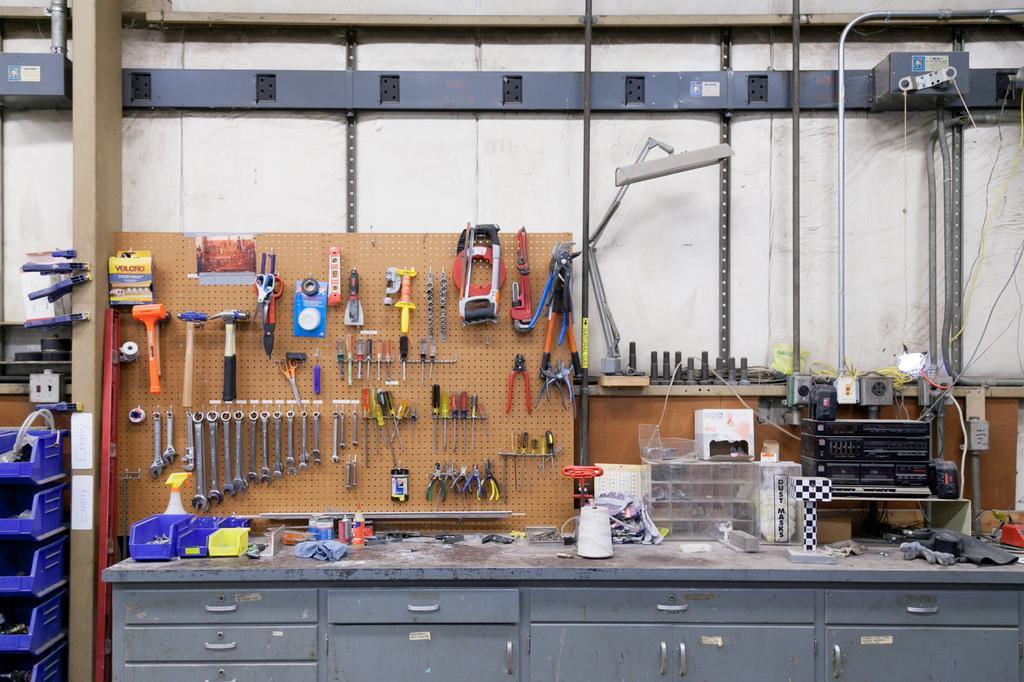How would you summarize this image in a sentence or two? At the bottom of the image there is a table with cupboards, bottles, black machine and some other things. There is a board behind the table with hammers, screwdrivers, cutting pliers, scissors and many other tools. Behind the board there is a wall with pipes, poles, wires and a box. And also there are many other things on the wall. On the left of the image there are blue boxes and also some other things. There is a wooden pole with a few things on it. 